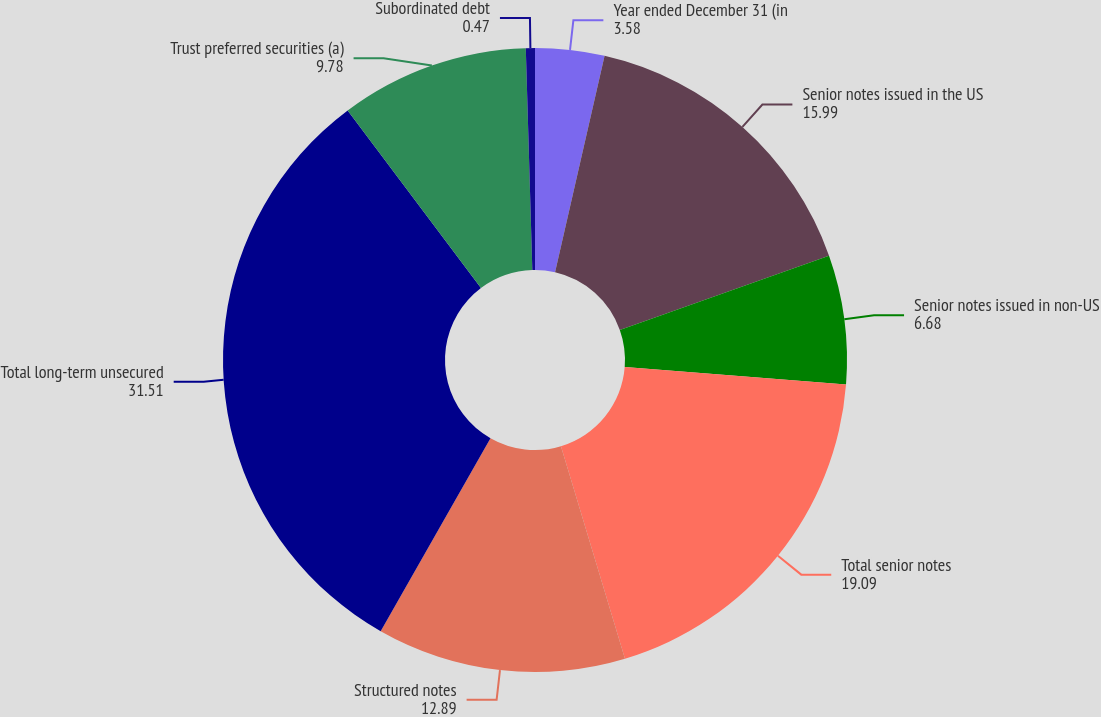Convert chart to OTSL. <chart><loc_0><loc_0><loc_500><loc_500><pie_chart><fcel>Year ended December 31 (in<fcel>Senior notes issued in the US<fcel>Senior notes issued in non-US<fcel>Total senior notes<fcel>Structured notes<fcel>Total long-term unsecured<fcel>Trust preferred securities (a)<fcel>Subordinated debt<nl><fcel>3.58%<fcel>15.99%<fcel>6.68%<fcel>19.09%<fcel>12.89%<fcel>31.51%<fcel>9.78%<fcel>0.47%<nl></chart> 